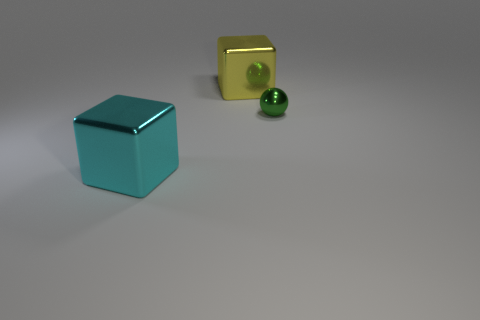Add 3 spheres. How many objects exist? 6 Subtract all cubes. Subtract all tiny things. How many objects are left? 0 Add 1 balls. How many balls are left? 2 Add 1 tiny green things. How many tiny green things exist? 2 Subtract 0 blue balls. How many objects are left? 3 Subtract all blocks. How many objects are left? 1 Subtract all red balls. Subtract all yellow cylinders. How many balls are left? 1 